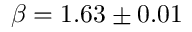Convert formula to latex. <formula><loc_0><loc_0><loc_500><loc_500>\beta = 1 . 6 3 \pm 0 . 0 1</formula> 